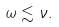<formula> <loc_0><loc_0><loc_500><loc_500>\omega \lesssim \nu .</formula> 